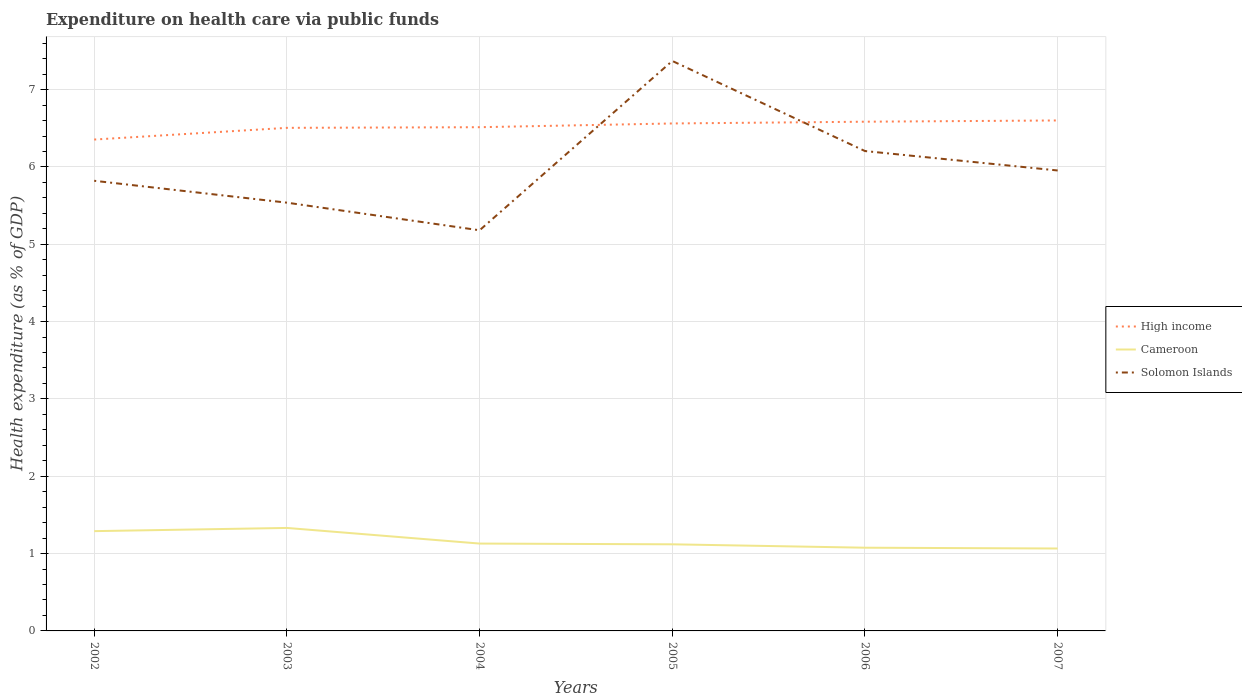Does the line corresponding to Cameroon intersect with the line corresponding to Solomon Islands?
Make the answer very short. No. Is the number of lines equal to the number of legend labels?
Provide a short and direct response. Yes. Across all years, what is the maximum expenditure made on health care in Solomon Islands?
Your answer should be very brief. 5.18. What is the total expenditure made on health care in High income in the graph?
Your answer should be very brief. -0.02. What is the difference between the highest and the second highest expenditure made on health care in High income?
Provide a succinct answer. 0.25. What is the difference between two consecutive major ticks on the Y-axis?
Ensure brevity in your answer.  1. Where does the legend appear in the graph?
Give a very brief answer. Center right. How many legend labels are there?
Offer a very short reply. 3. What is the title of the graph?
Give a very brief answer. Expenditure on health care via public funds. Does "Lithuania" appear as one of the legend labels in the graph?
Your response must be concise. No. What is the label or title of the X-axis?
Give a very brief answer. Years. What is the label or title of the Y-axis?
Offer a very short reply. Health expenditure (as % of GDP). What is the Health expenditure (as % of GDP) of High income in 2002?
Make the answer very short. 6.35. What is the Health expenditure (as % of GDP) of Cameroon in 2002?
Offer a very short reply. 1.29. What is the Health expenditure (as % of GDP) in Solomon Islands in 2002?
Ensure brevity in your answer.  5.82. What is the Health expenditure (as % of GDP) in High income in 2003?
Your answer should be very brief. 6.51. What is the Health expenditure (as % of GDP) of Cameroon in 2003?
Provide a succinct answer. 1.33. What is the Health expenditure (as % of GDP) in Solomon Islands in 2003?
Provide a succinct answer. 5.54. What is the Health expenditure (as % of GDP) in High income in 2004?
Provide a succinct answer. 6.51. What is the Health expenditure (as % of GDP) of Cameroon in 2004?
Offer a very short reply. 1.13. What is the Health expenditure (as % of GDP) of Solomon Islands in 2004?
Provide a succinct answer. 5.18. What is the Health expenditure (as % of GDP) of High income in 2005?
Your response must be concise. 6.56. What is the Health expenditure (as % of GDP) in Cameroon in 2005?
Ensure brevity in your answer.  1.12. What is the Health expenditure (as % of GDP) in Solomon Islands in 2005?
Offer a terse response. 7.37. What is the Health expenditure (as % of GDP) in High income in 2006?
Keep it short and to the point. 6.58. What is the Health expenditure (as % of GDP) of Cameroon in 2006?
Give a very brief answer. 1.08. What is the Health expenditure (as % of GDP) of Solomon Islands in 2006?
Ensure brevity in your answer.  6.21. What is the Health expenditure (as % of GDP) of High income in 2007?
Ensure brevity in your answer.  6.6. What is the Health expenditure (as % of GDP) in Cameroon in 2007?
Offer a terse response. 1.07. What is the Health expenditure (as % of GDP) in Solomon Islands in 2007?
Make the answer very short. 5.95. Across all years, what is the maximum Health expenditure (as % of GDP) in High income?
Your answer should be compact. 6.6. Across all years, what is the maximum Health expenditure (as % of GDP) of Cameroon?
Give a very brief answer. 1.33. Across all years, what is the maximum Health expenditure (as % of GDP) in Solomon Islands?
Ensure brevity in your answer.  7.37. Across all years, what is the minimum Health expenditure (as % of GDP) of High income?
Offer a terse response. 6.35. Across all years, what is the minimum Health expenditure (as % of GDP) in Cameroon?
Offer a terse response. 1.07. Across all years, what is the minimum Health expenditure (as % of GDP) in Solomon Islands?
Keep it short and to the point. 5.18. What is the total Health expenditure (as % of GDP) in High income in the graph?
Give a very brief answer. 39.12. What is the total Health expenditure (as % of GDP) of Cameroon in the graph?
Give a very brief answer. 7.01. What is the total Health expenditure (as % of GDP) in Solomon Islands in the graph?
Your answer should be very brief. 36.07. What is the difference between the Health expenditure (as % of GDP) in High income in 2002 and that in 2003?
Keep it short and to the point. -0.15. What is the difference between the Health expenditure (as % of GDP) in Cameroon in 2002 and that in 2003?
Provide a short and direct response. -0.04. What is the difference between the Health expenditure (as % of GDP) of Solomon Islands in 2002 and that in 2003?
Ensure brevity in your answer.  0.28. What is the difference between the Health expenditure (as % of GDP) in High income in 2002 and that in 2004?
Your answer should be compact. -0.16. What is the difference between the Health expenditure (as % of GDP) in Cameroon in 2002 and that in 2004?
Offer a terse response. 0.16. What is the difference between the Health expenditure (as % of GDP) in Solomon Islands in 2002 and that in 2004?
Offer a very short reply. 0.64. What is the difference between the Health expenditure (as % of GDP) in High income in 2002 and that in 2005?
Make the answer very short. -0.21. What is the difference between the Health expenditure (as % of GDP) of Cameroon in 2002 and that in 2005?
Your response must be concise. 0.17. What is the difference between the Health expenditure (as % of GDP) in Solomon Islands in 2002 and that in 2005?
Provide a short and direct response. -1.55. What is the difference between the Health expenditure (as % of GDP) in High income in 2002 and that in 2006?
Provide a short and direct response. -0.23. What is the difference between the Health expenditure (as % of GDP) in Cameroon in 2002 and that in 2006?
Make the answer very short. 0.21. What is the difference between the Health expenditure (as % of GDP) of Solomon Islands in 2002 and that in 2006?
Offer a very short reply. -0.38. What is the difference between the Health expenditure (as % of GDP) of High income in 2002 and that in 2007?
Offer a terse response. -0.25. What is the difference between the Health expenditure (as % of GDP) in Cameroon in 2002 and that in 2007?
Make the answer very short. 0.22. What is the difference between the Health expenditure (as % of GDP) of Solomon Islands in 2002 and that in 2007?
Provide a succinct answer. -0.13. What is the difference between the Health expenditure (as % of GDP) in High income in 2003 and that in 2004?
Give a very brief answer. -0.01. What is the difference between the Health expenditure (as % of GDP) of Cameroon in 2003 and that in 2004?
Offer a very short reply. 0.2. What is the difference between the Health expenditure (as % of GDP) of Solomon Islands in 2003 and that in 2004?
Ensure brevity in your answer.  0.36. What is the difference between the Health expenditure (as % of GDP) of High income in 2003 and that in 2005?
Provide a succinct answer. -0.06. What is the difference between the Health expenditure (as % of GDP) in Cameroon in 2003 and that in 2005?
Provide a short and direct response. 0.21. What is the difference between the Health expenditure (as % of GDP) in Solomon Islands in 2003 and that in 2005?
Give a very brief answer. -1.83. What is the difference between the Health expenditure (as % of GDP) in High income in 2003 and that in 2006?
Offer a very short reply. -0.08. What is the difference between the Health expenditure (as % of GDP) in Cameroon in 2003 and that in 2006?
Provide a short and direct response. 0.26. What is the difference between the Health expenditure (as % of GDP) in Solomon Islands in 2003 and that in 2006?
Provide a succinct answer. -0.67. What is the difference between the Health expenditure (as % of GDP) in High income in 2003 and that in 2007?
Keep it short and to the point. -0.1. What is the difference between the Health expenditure (as % of GDP) in Cameroon in 2003 and that in 2007?
Ensure brevity in your answer.  0.27. What is the difference between the Health expenditure (as % of GDP) of Solomon Islands in 2003 and that in 2007?
Ensure brevity in your answer.  -0.42. What is the difference between the Health expenditure (as % of GDP) in High income in 2004 and that in 2005?
Give a very brief answer. -0.05. What is the difference between the Health expenditure (as % of GDP) in Cameroon in 2004 and that in 2005?
Provide a succinct answer. 0.01. What is the difference between the Health expenditure (as % of GDP) in Solomon Islands in 2004 and that in 2005?
Your response must be concise. -2.19. What is the difference between the Health expenditure (as % of GDP) in High income in 2004 and that in 2006?
Offer a very short reply. -0.07. What is the difference between the Health expenditure (as % of GDP) in Cameroon in 2004 and that in 2006?
Offer a very short reply. 0.05. What is the difference between the Health expenditure (as % of GDP) of Solomon Islands in 2004 and that in 2006?
Make the answer very short. -1.02. What is the difference between the Health expenditure (as % of GDP) of High income in 2004 and that in 2007?
Make the answer very short. -0.09. What is the difference between the Health expenditure (as % of GDP) in Cameroon in 2004 and that in 2007?
Your answer should be compact. 0.06. What is the difference between the Health expenditure (as % of GDP) of Solomon Islands in 2004 and that in 2007?
Give a very brief answer. -0.77. What is the difference between the Health expenditure (as % of GDP) in High income in 2005 and that in 2006?
Your answer should be very brief. -0.02. What is the difference between the Health expenditure (as % of GDP) of Cameroon in 2005 and that in 2006?
Offer a very short reply. 0.04. What is the difference between the Health expenditure (as % of GDP) of Solomon Islands in 2005 and that in 2006?
Provide a succinct answer. 1.17. What is the difference between the Health expenditure (as % of GDP) in High income in 2005 and that in 2007?
Your response must be concise. -0.04. What is the difference between the Health expenditure (as % of GDP) in Cameroon in 2005 and that in 2007?
Offer a terse response. 0.05. What is the difference between the Health expenditure (as % of GDP) of Solomon Islands in 2005 and that in 2007?
Offer a terse response. 1.42. What is the difference between the Health expenditure (as % of GDP) of High income in 2006 and that in 2007?
Give a very brief answer. -0.02. What is the difference between the Health expenditure (as % of GDP) in Cameroon in 2006 and that in 2007?
Your answer should be very brief. 0.01. What is the difference between the Health expenditure (as % of GDP) in Solomon Islands in 2006 and that in 2007?
Your answer should be very brief. 0.25. What is the difference between the Health expenditure (as % of GDP) of High income in 2002 and the Health expenditure (as % of GDP) of Cameroon in 2003?
Give a very brief answer. 5.02. What is the difference between the Health expenditure (as % of GDP) in High income in 2002 and the Health expenditure (as % of GDP) in Solomon Islands in 2003?
Provide a short and direct response. 0.82. What is the difference between the Health expenditure (as % of GDP) of Cameroon in 2002 and the Health expenditure (as % of GDP) of Solomon Islands in 2003?
Provide a short and direct response. -4.25. What is the difference between the Health expenditure (as % of GDP) of High income in 2002 and the Health expenditure (as % of GDP) of Cameroon in 2004?
Offer a terse response. 5.22. What is the difference between the Health expenditure (as % of GDP) of High income in 2002 and the Health expenditure (as % of GDP) of Solomon Islands in 2004?
Provide a succinct answer. 1.17. What is the difference between the Health expenditure (as % of GDP) of Cameroon in 2002 and the Health expenditure (as % of GDP) of Solomon Islands in 2004?
Provide a succinct answer. -3.89. What is the difference between the Health expenditure (as % of GDP) of High income in 2002 and the Health expenditure (as % of GDP) of Cameroon in 2005?
Provide a succinct answer. 5.23. What is the difference between the Health expenditure (as % of GDP) in High income in 2002 and the Health expenditure (as % of GDP) in Solomon Islands in 2005?
Your answer should be very brief. -1.02. What is the difference between the Health expenditure (as % of GDP) of Cameroon in 2002 and the Health expenditure (as % of GDP) of Solomon Islands in 2005?
Keep it short and to the point. -6.08. What is the difference between the Health expenditure (as % of GDP) of High income in 2002 and the Health expenditure (as % of GDP) of Cameroon in 2006?
Ensure brevity in your answer.  5.28. What is the difference between the Health expenditure (as % of GDP) in High income in 2002 and the Health expenditure (as % of GDP) in Solomon Islands in 2006?
Provide a short and direct response. 0.15. What is the difference between the Health expenditure (as % of GDP) of Cameroon in 2002 and the Health expenditure (as % of GDP) of Solomon Islands in 2006?
Your response must be concise. -4.92. What is the difference between the Health expenditure (as % of GDP) in High income in 2002 and the Health expenditure (as % of GDP) in Cameroon in 2007?
Offer a terse response. 5.29. What is the difference between the Health expenditure (as % of GDP) of High income in 2002 and the Health expenditure (as % of GDP) of Solomon Islands in 2007?
Provide a short and direct response. 0.4. What is the difference between the Health expenditure (as % of GDP) of Cameroon in 2002 and the Health expenditure (as % of GDP) of Solomon Islands in 2007?
Your answer should be compact. -4.66. What is the difference between the Health expenditure (as % of GDP) in High income in 2003 and the Health expenditure (as % of GDP) in Cameroon in 2004?
Ensure brevity in your answer.  5.38. What is the difference between the Health expenditure (as % of GDP) of High income in 2003 and the Health expenditure (as % of GDP) of Solomon Islands in 2004?
Offer a terse response. 1.32. What is the difference between the Health expenditure (as % of GDP) in Cameroon in 2003 and the Health expenditure (as % of GDP) in Solomon Islands in 2004?
Your answer should be very brief. -3.85. What is the difference between the Health expenditure (as % of GDP) in High income in 2003 and the Health expenditure (as % of GDP) in Cameroon in 2005?
Offer a terse response. 5.39. What is the difference between the Health expenditure (as % of GDP) in High income in 2003 and the Health expenditure (as % of GDP) in Solomon Islands in 2005?
Your response must be concise. -0.86. What is the difference between the Health expenditure (as % of GDP) in Cameroon in 2003 and the Health expenditure (as % of GDP) in Solomon Islands in 2005?
Your response must be concise. -6.04. What is the difference between the Health expenditure (as % of GDP) in High income in 2003 and the Health expenditure (as % of GDP) in Cameroon in 2006?
Your answer should be compact. 5.43. What is the difference between the Health expenditure (as % of GDP) of High income in 2003 and the Health expenditure (as % of GDP) of Solomon Islands in 2006?
Your answer should be compact. 0.3. What is the difference between the Health expenditure (as % of GDP) in Cameroon in 2003 and the Health expenditure (as % of GDP) in Solomon Islands in 2006?
Provide a succinct answer. -4.87. What is the difference between the Health expenditure (as % of GDP) in High income in 2003 and the Health expenditure (as % of GDP) in Cameroon in 2007?
Make the answer very short. 5.44. What is the difference between the Health expenditure (as % of GDP) of High income in 2003 and the Health expenditure (as % of GDP) of Solomon Islands in 2007?
Give a very brief answer. 0.55. What is the difference between the Health expenditure (as % of GDP) in Cameroon in 2003 and the Health expenditure (as % of GDP) in Solomon Islands in 2007?
Make the answer very short. -4.62. What is the difference between the Health expenditure (as % of GDP) in High income in 2004 and the Health expenditure (as % of GDP) in Cameroon in 2005?
Ensure brevity in your answer.  5.39. What is the difference between the Health expenditure (as % of GDP) in High income in 2004 and the Health expenditure (as % of GDP) in Solomon Islands in 2005?
Ensure brevity in your answer.  -0.86. What is the difference between the Health expenditure (as % of GDP) of Cameroon in 2004 and the Health expenditure (as % of GDP) of Solomon Islands in 2005?
Ensure brevity in your answer.  -6.24. What is the difference between the Health expenditure (as % of GDP) in High income in 2004 and the Health expenditure (as % of GDP) in Cameroon in 2006?
Ensure brevity in your answer.  5.44. What is the difference between the Health expenditure (as % of GDP) of High income in 2004 and the Health expenditure (as % of GDP) of Solomon Islands in 2006?
Your answer should be very brief. 0.31. What is the difference between the Health expenditure (as % of GDP) in Cameroon in 2004 and the Health expenditure (as % of GDP) in Solomon Islands in 2006?
Your answer should be compact. -5.08. What is the difference between the Health expenditure (as % of GDP) of High income in 2004 and the Health expenditure (as % of GDP) of Cameroon in 2007?
Your answer should be very brief. 5.45. What is the difference between the Health expenditure (as % of GDP) in High income in 2004 and the Health expenditure (as % of GDP) in Solomon Islands in 2007?
Give a very brief answer. 0.56. What is the difference between the Health expenditure (as % of GDP) of Cameroon in 2004 and the Health expenditure (as % of GDP) of Solomon Islands in 2007?
Keep it short and to the point. -4.82. What is the difference between the Health expenditure (as % of GDP) of High income in 2005 and the Health expenditure (as % of GDP) of Cameroon in 2006?
Ensure brevity in your answer.  5.49. What is the difference between the Health expenditure (as % of GDP) of High income in 2005 and the Health expenditure (as % of GDP) of Solomon Islands in 2006?
Give a very brief answer. 0.36. What is the difference between the Health expenditure (as % of GDP) of Cameroon in 2005 and the Health expenditure (as % of GDP) of Solomon Islands in 2006?
Provide a succinct answer. -5.09. What is the difference between the Health expenditure (as % of GDP) of High income in 2005 and the Health expenditure (as % of GDP) of Cameroon in 2007?
Provide a short and direct response. 5.5. What is the difference between the Health expenditure (as % of GDP) of High income in 2005 and the Health expenditure (as % of GDP) of Solomon Islands in 2007?
Provide a short and direct response. 0.61. What is the difference between the Health expenditure (as % of GDP) of Cameroon in 2005 and the Health expenditure (as % of GDP) of Solomon Islands in 2007?
Make the answer very short. -4.83. What is the difference between the Health expenditure (as % of GDP) in High income in 2006 and the Health expenditure (as % of GDP) in Cameroon in 2007?
Your response must be concise. 5.52. What is the difference between the Health expenditure (as % of GDP) in High income in 2006 and the Health expenditure (as % of GDP) in Solomon Islands in 2007?
Provide a succinct answer. 0.63. What is the difference between the Health expenditure (as % of GDP) in Cameroon in 2006 and the Health expenditure (as % of GDP) in Solomon Islands in 2007?
Your response must be concise. -4.88. What is the average Health expenditure (as % of GDP) in High income per year?
Offer a terse response. 6.52. What is the average Health expenditure (as % of GDP) in Cameroon per year?
Ensure brevity in your answer.  1.17. What is the average Health expenditure (as % of GDP) of Solomon Islands per year?
Provide a short and direct response. 6.01. In the year 2002, what is the difference between the Health expenditure (as % of GDP) in High income and Health expenditure (as % of GDP) in Cameroon?
Keep it short and to the point. 5.06. In the year 2002, what is the difference between the Health expenditure (as % of GDP) in High income and Health expenditure (as % of GDP) in Solomon Islands?
Ensure brevity in your answer.  0.53. In the year 2002, what is the difference between the Health expenditure (as % of GDP) in Cameroon and Health expenditure (as % of GDP) in Solomon Islands?
Give a very brief answer. -4.53. In the year 2003, what is the difference between the Health expenditure (as % of GDP) in High income and Health expenditure (as % of GDP) in Cameroon?
Offer a terse response. 5.17. In the year 2003, what is the difference between the Health expenditure (as % of GDP) in High income and Health expenditure (as % of GDP) in Solomon Islands?
Make the answer very short. 0.97. In the year 2003, what is the difference between the Health expenditure (as % of GDP) in Cameroon and Health expenditure (as % of GDP) in Solomon Islands?
Provide a succinct answer. -4.21. In the year 2004, what is the difference between the Health expenditure (as % of GDP) in High income and Health expenditure (as % of GDP) in Cameroon?
Give a very brief answer. 5.38. In the year 2004, what is the difference between the Health expenditure (as % of GDP) in High income and Health expenditure (as % of GDP) in Solomon Islands?
Make the answer very short. 1.33. In the year 2004, what is the difference between the Health expenditure (as % of GDP) in Cameroon and Health expenditure (as % of GDP) in Solomon Islands?
Make the answer very short. -4.05. In the year 2005, what is the difference between the Health expenditure (as % of GDP) in High income and Health expenditure (as % of GDP) in Cameroon?
Your response must be concise. 5.44. In the year 2005, what is the difference between the Health expenditure (as % of GDP) of High income and Health expenditure (as % of GDP) of Solomon Islands?
Your answer should be very brief. -0.81. In the year 2005, what is the difference between the Health expenditure (as % of GDP) in Cameroon and Health expenditure (as % of GDP) in Solomon Islands?
Make the answer very short. -6.25. In the year 2006, what is the difference between the Health expenditure (as % of GDP) of High income and Health expenditure (as % of GDP) of Cameroon?
Keep it short and to the point. 5.51. In the year 2006, what is the difference between the Health expenditure (as % of GDP) in High income and Health expenditure (as % of GDP) in Solomon Islands?
Make the answer very short. 0.38. In the year 2006, what is the difference between the Health expenditure (as % of GDP) in Cameroon and Health expenditure (as % of GDP) in Solomon Islands?
Offer a terse response. -5.13. In the year 2007, what is the difference between the Health expenditure (as % of GDP) of High income and Health expenditure (as % of GDP) of Cameroon?
Provide a short and direct response. 5.54. In the year 2007, what is the difference between the Health expenditure (as % of GDP) in High income and Health expenditure (as % of GDP) in Solomon Islands?
Offer a terse response. 0.65. In the year 2007, what is the difference between the Health expenditure (as % of GDP) of Cameroon and Health expenditure (as % of GDP) of Solomon Islands?
Give a very brief answer. -4.89. What is the ratio of the Health expenditure (as % of GDP) in High income in 2002 to that in 2003?
Give a very brief answer. 0.98. What is the ratio of the Health expenditure (as % of GDP) of Cameroon in 2002 to that in 2003?
Give a very brief answer. 0.97. What is the ratio of the Health expenditure (as % of GDP) of Solomon Islands in 2002 to that in 2003?
Your answer should be compact. 1.05. What is the ratio of the Health expenditure (as % of GDP) of High income in 2002 to that in 2004?
Give a very brief answer. 0.98. What is the ratio of the Health expenditure (as % of GDP) in Cameroon in 2002 to that in 2004?
Provide a succinct answer. 1.14. What is the ratio of the Health expenditure (as % of GDP) in Solomon Islands in 2002 to that in 2004?
Offer a very short reply. 1.12. What is the ratio of the Health expenditure (as % of GDP) of High income in 2002 to that in 2005?
Provide a short and direct response. 0.97. What is the ratio of the Health expenditure (as % of GDP) of Cameroon in 2002 to that in 2005?
Your response must be concise. 1.15. What is the ratio of the Health expenditure (as % of GDP) of Solomon Islands in 2002 to that in 2005?
Provide a short and direct response. 0.79. What is the ratio of the Health expenditure (as % of GDP) of High income in 2002 to that in 2006?
Your response must be concise. 0.96. What is the ratio of the Health expenditure (as % of GDP) of Cameroon in 2002 to that in 2006?
Your answer should be compact. 1.2. What is the ratio of the Health expenditure (as % of GDP) in Solomon Islands in 2002 to that in 2006?
Give a very brief answer. 0.94. What is the ratio of the Health expenditure (as % of GDP) in High income in 2002 to that in 2007?
Provide a succinct answer. 0.96. What is the ratio of the Health expenditure (as % of GDP) of Cameroon in 2002 to that in 2007?
Offer a terse response. 1.21. What is the ratio of the Health expenditure (as % of GDP) of Solomon Islands in 2002 to that in 2007?
Offer a terse response. 0.98. What is the ratio of the Health expenditure (as % of GDP) of Cameroon in 2003 to that in 2004?
Offer a terse response. 1.18. What is the ratio of the Health expenditure (as % of GDP) in Solomon Islands in 2003 to that in 2004?
Offer a terse response. 1.07. What is the ratio of the Health expenditure (as % of GDP) in High income in 2003 to that in 2005?
Your answer should be very brief. 0.99. What is the ratio of the Health expenditure (as % of GDP) of Cameroon in 2003 to that in 2005?
Your answer should be compact. 1.19. What is the ratio of the Health expenditure (as % of GDP) in Solomon Islands in 2003 to that in 2005?
Keep it short and to the point. 0.75. What is the ratio of the Health expenditure (as % of GDP) of High income in 2003 to that in 2006?
Keep it short and to the point. 0.99. What is the ratio of the Health expenditure (as % of GDP) in Cameroon in 2003 to that in 2006?
Provide a succinct answer. 1.24. What is the ratio of the Health expenditure (as % of GDP) in Solomon Islands in 2003 to that in 2006?
Your answer should be compact. 0.89. What is the ratio of the Health expenditure (as % of GDP) in High income in 2003 to that in 2007?
Offer a terse response. 0.99. What is the ratio of the Health expenditure (as % of GDP) of Cameroon in 2003 to that in 2007?
Offer a terse response. 1.25. What is the ratio of the Health expenditure (as % of GDP) in Solomon Islands in 2003 to that in 2007?
Keep it short and to the point. 0.93. What is the ratio of the Health expenditure (as % of GDP) of Cameroon in 2004 to that in 2005?
Make the answer very short. 1.01. What is the ratio of the Health expenditure (as % of GDP) in Solomon Islands in 2004 to that in 2005?
Make the answer very short. 0.7. What is the ratio of the Health expenditure (as % of GDP) of High income in 2004 to that in 2006?
Your answer should be very brief. 0.99. What is the ratio of the Health expenditure (as % of GDP) of Cameroon in 2004 to that in 2006?
Provide a succinct answer. 1.05. What is the ratio of the Health expenditure (as % of GDP) in Solomon Islands in 2004 to that in 2006?
Provide a succinct answer. 0.83. What is the ratio of the Health expenditure (as % of GDP) in Cameroon in 2004 to that in 2007?
Offer a very short reply. 1.06. What is the ratio of the Health expenditure (as % of GDP) of Solomon Islands in 2004 to that in 2007?
Keep it short and to the point. 0.87. What is the ratio of the Health expenditure (as % of GDP) in Cameroon in 2005 to that in 2006?
Your answer should be very brief. 1.04. What is the ratio of the Health expenditure (as % of GDP) in Solomon Islands in 2005 to that in 2006?
Offer a terse response. 1.19. What is the ratio of the Health expenditure (as % of GDP) of Cameroon in 2005 to that in 2007?
Ensure brevity in your answer.  1.05. What is the ratio of the Health expenditure (as % of GDP) of Solomon Islands in 2005 to that in 2007?
Provide a short and direct response. 1.24. What is the ratio of the Health expenditure (as % of GDP) in High income in 2006 to that in 2007?
Make the answer very short. 1. What is the ratio of the Health expenditure (as % of GDP) of Cameroon in 2006 to that in 2007?
Give a very brief answer. 1.01. What is the ratio of the Health expenditure (as % of GDP) in Solomon Islands in 2006 to that in 2007?
Ensure brevity in your answer.  1.04. What is the difference between the highest and the second highest Health expenditure (as % of GDP) of High income?
Offer a very short reply. 0.02. What is the difference between the highest and the second highest Health expenditure (as % of GDP) in Cameroon?
Give a very brief answer. 0.04. What is the difference between the highest and the second highest Health expenditure (as % of GDP) in Solomon Islands?
Ensure brevity in your answer.  1.17. What is the difference between the highest and the lowest Health expenditure (as % of GDP) of High income?
Make the answer very short. 0.25. What is the difference between the highest and the lowest Health expenditure (as % of GDP) of Cameroon?
Make the answer very short. 0.27. What is the difference between the highest and the lowest Health expenditure (as % of GDP) of Solomon Islands?
Offer a terse response. 2.19. 